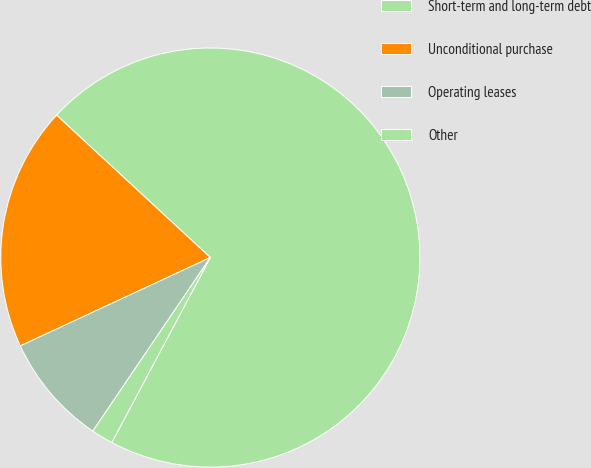Convert chart. <chart><loc_0><loc_0><loc_500><loc_500><pie_chart><fcel>Short-term and long-term debt<fcel>Unconditional purchase<fcel>Operating leases<fcel>Other<nl><fcel>70.91%<fcel>18.82%<fcel>8.6%<fcel>1.68%<nl></chart> 